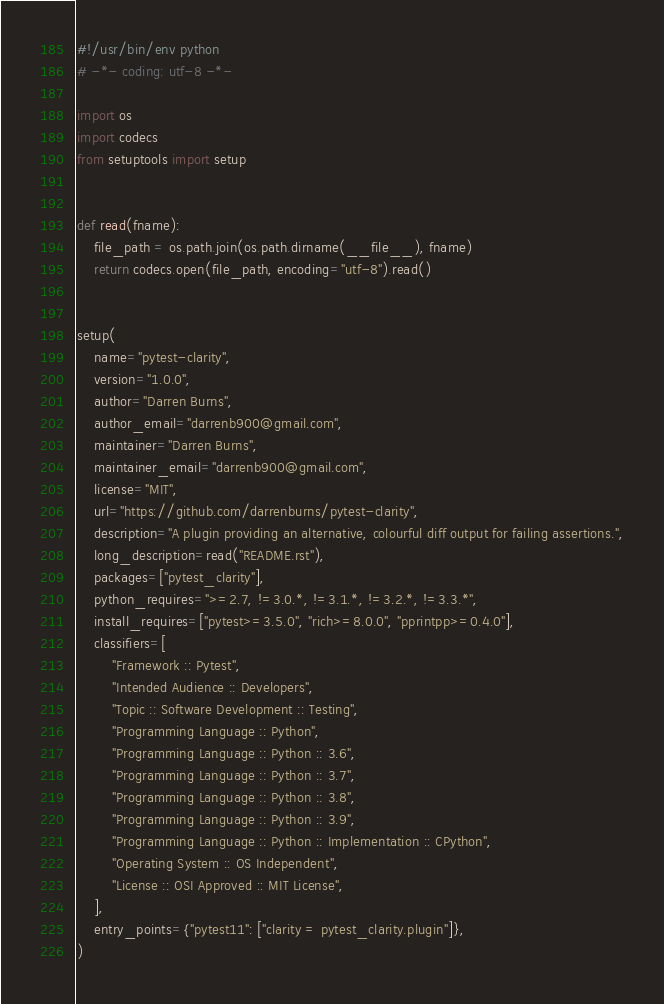<code> <loc_0><loc_0><loc_500><loc_500><_Python_>#!/usr/bin/env python
# -*- coding: utf-8 -*-

import os
import codecs
from setuptools import setup


def read(fname):
    file_path = os.path.join(os.path.dirname(__file__), fname)
    return codecs.open(file_path, encoding="utf-8").read()


setup(
    name="pytest-clarity",
    version="1.0.0",
    author="Darren Burns",
    author_email="darrenb900@gmail.com",
    maintainer="Darren Burns",
    maintainer_email="darrenb900@gmail.com",
    license="MIT",
    url="https://github.com/darrenburns/pytest-clarity",
    description="A plugin providing an alternative, colourful diff output for failing assertions.",
    long_description=read("README.rst"),
    packages=["pytest_clarity"],
    python_requires=">=2.7, !=3.0.*, !=3.1.*, !=3.2.*, !=3.3.*",
    install_requires=["pytest>=3.5.0", "rich>=8.0.0", "pprintpp>=0.4.0"],
    classifiers=[
        "Framework :: Pytest",
        "Intended Audience :: Developers",
        "Topic :: Software Development :: Testing",
        "Programming Language :: Python",
        "Programming Language :: Python :: 3.6",
        "Programming Language :: Python :: 3.7",
        "Programming Language :: Python :: 3.8",
        "Programming Language :: Python :: 3.9",
        "Programming Language :: Python :: Implementation :: CPython",
        "Operating System :: OS Independent",
        "License :: OSI Approved :: MIT License",
    ],
    entry_points={"pytest11": ["clarity = pytest_clarity.plugin"]},
)
</code> 